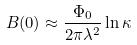<formula> <loc_0><loc_0><loc_500><loc_500>B ( 0 ) \approx \frac { \Phi _ { 0 } } { 2 \pi \lambda ^ { 2 } } \ln \kappa</formula> 